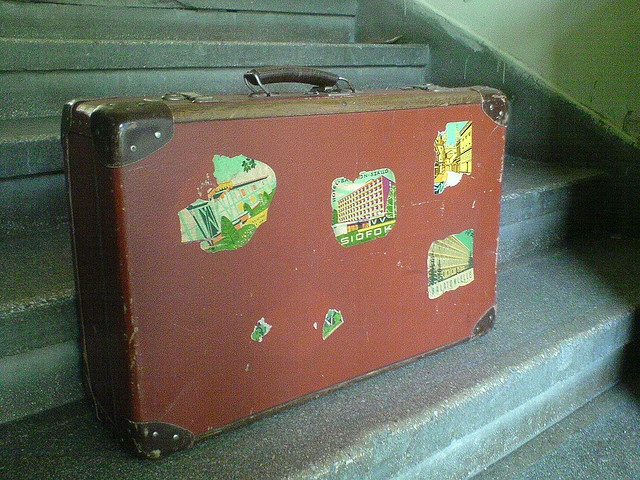Describe the objects in this image and their specific colors. I can see a suitcase in darkgreen, brown, black, gray, and maroon tones in this image. 